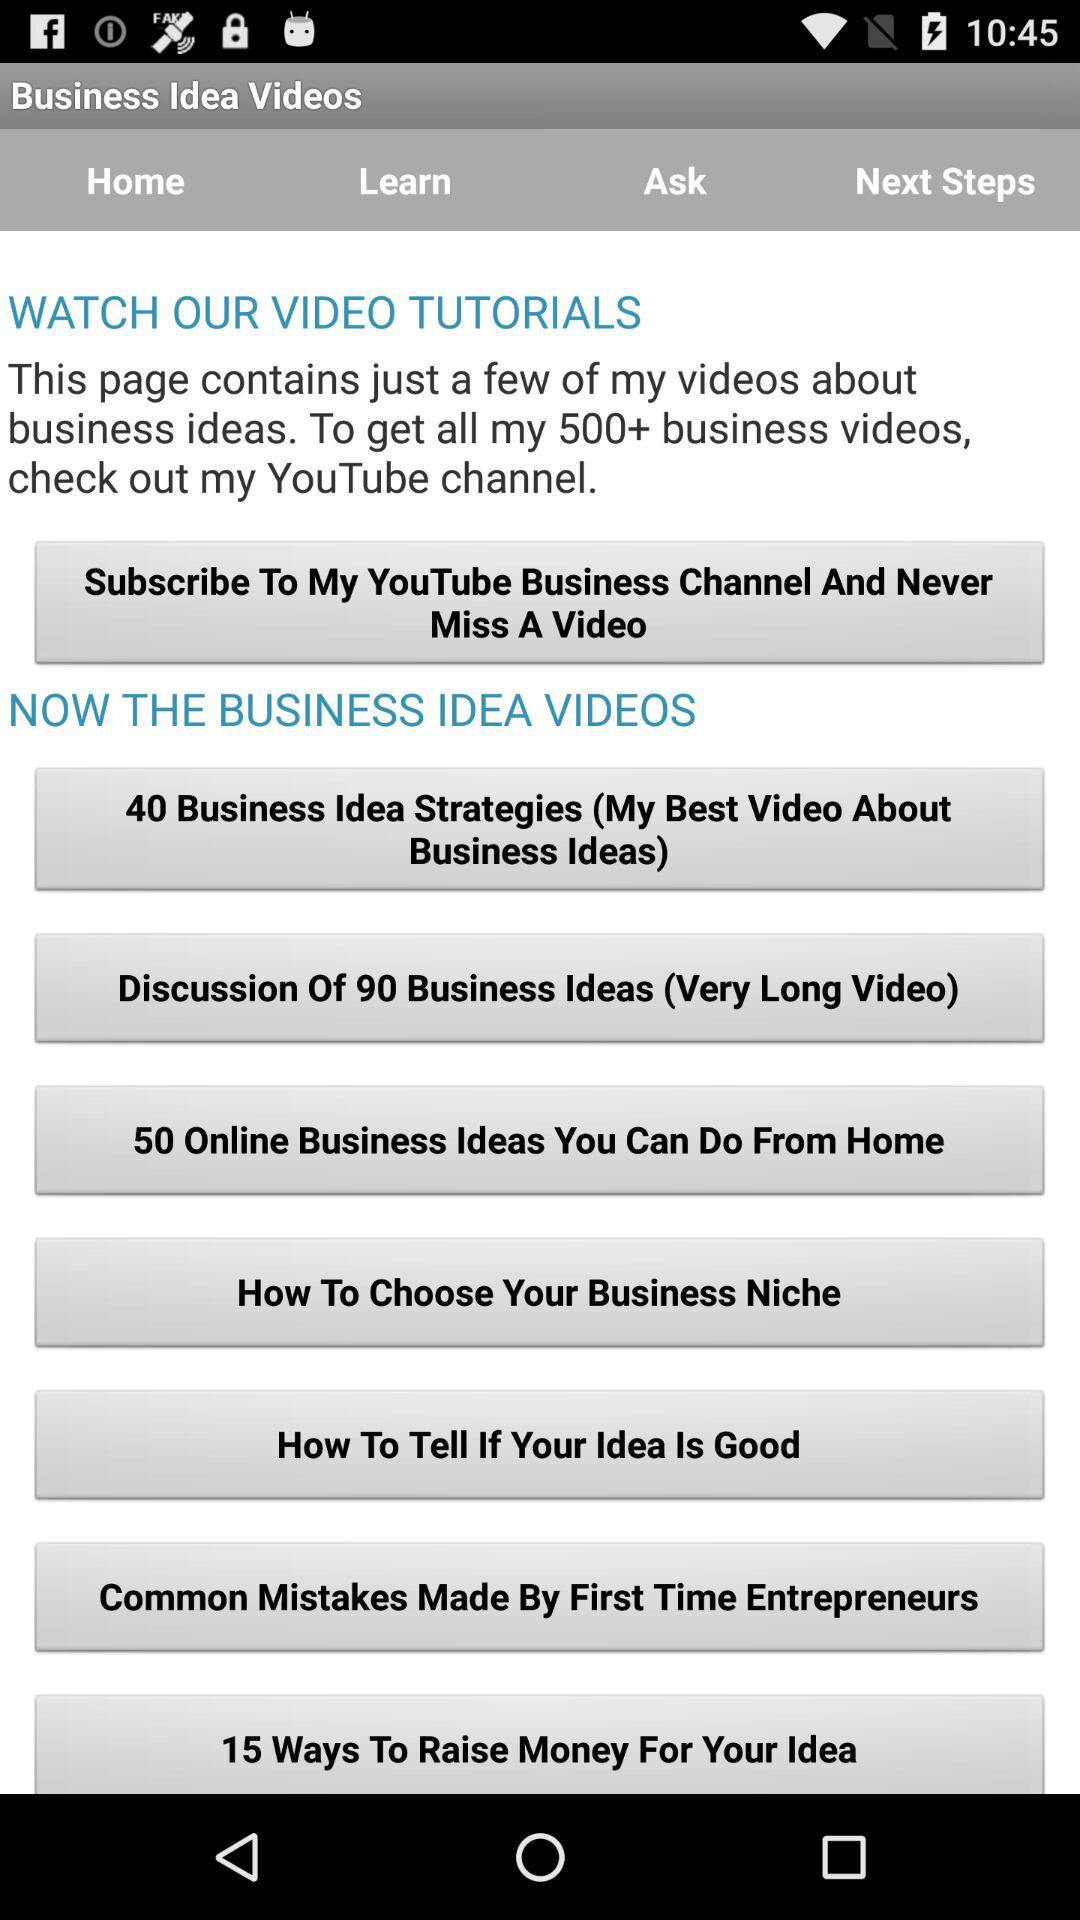What is the number of online business ideas we can do from home? The number of online business ideas you can do from home is 50. 